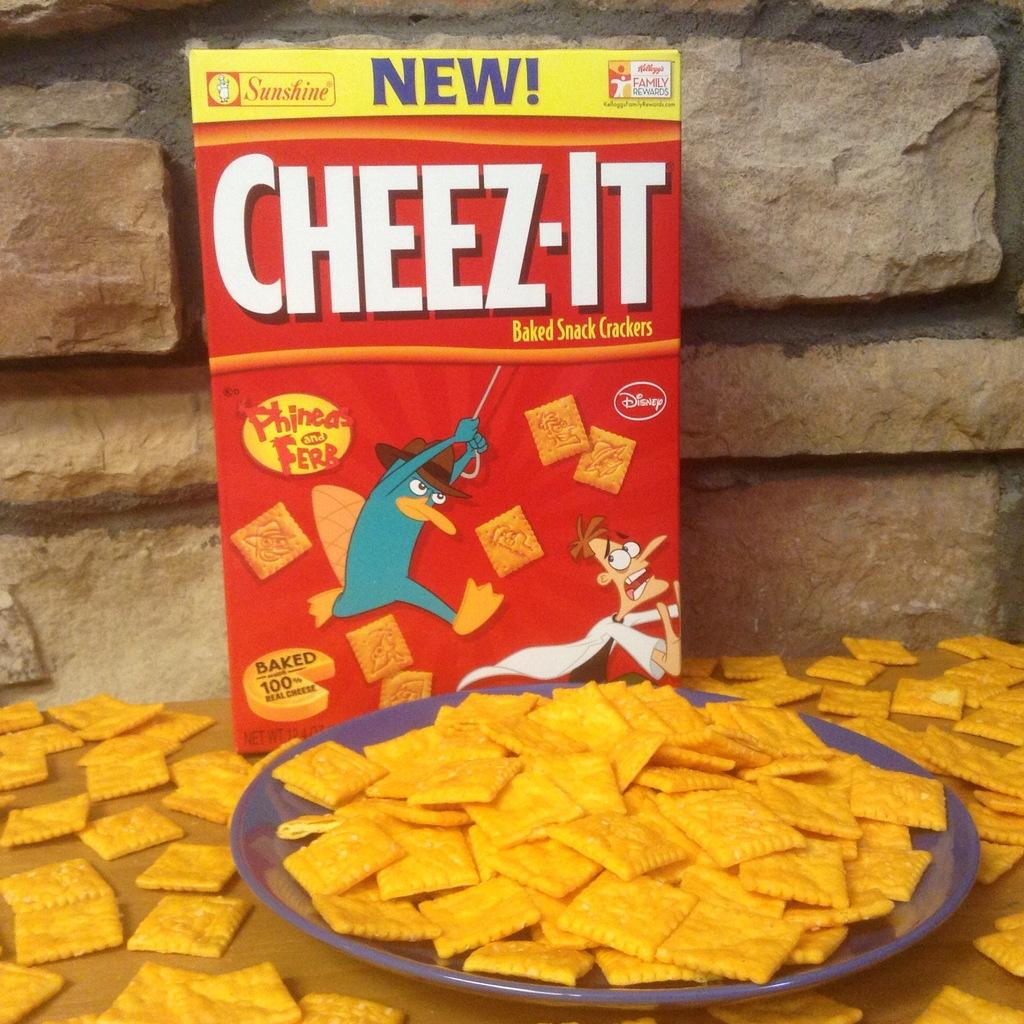<image>
Relay a brief, clear account of the picture shown. A yellow and red Cheez-it set on a table and a plate with cheez-it beside the box. 